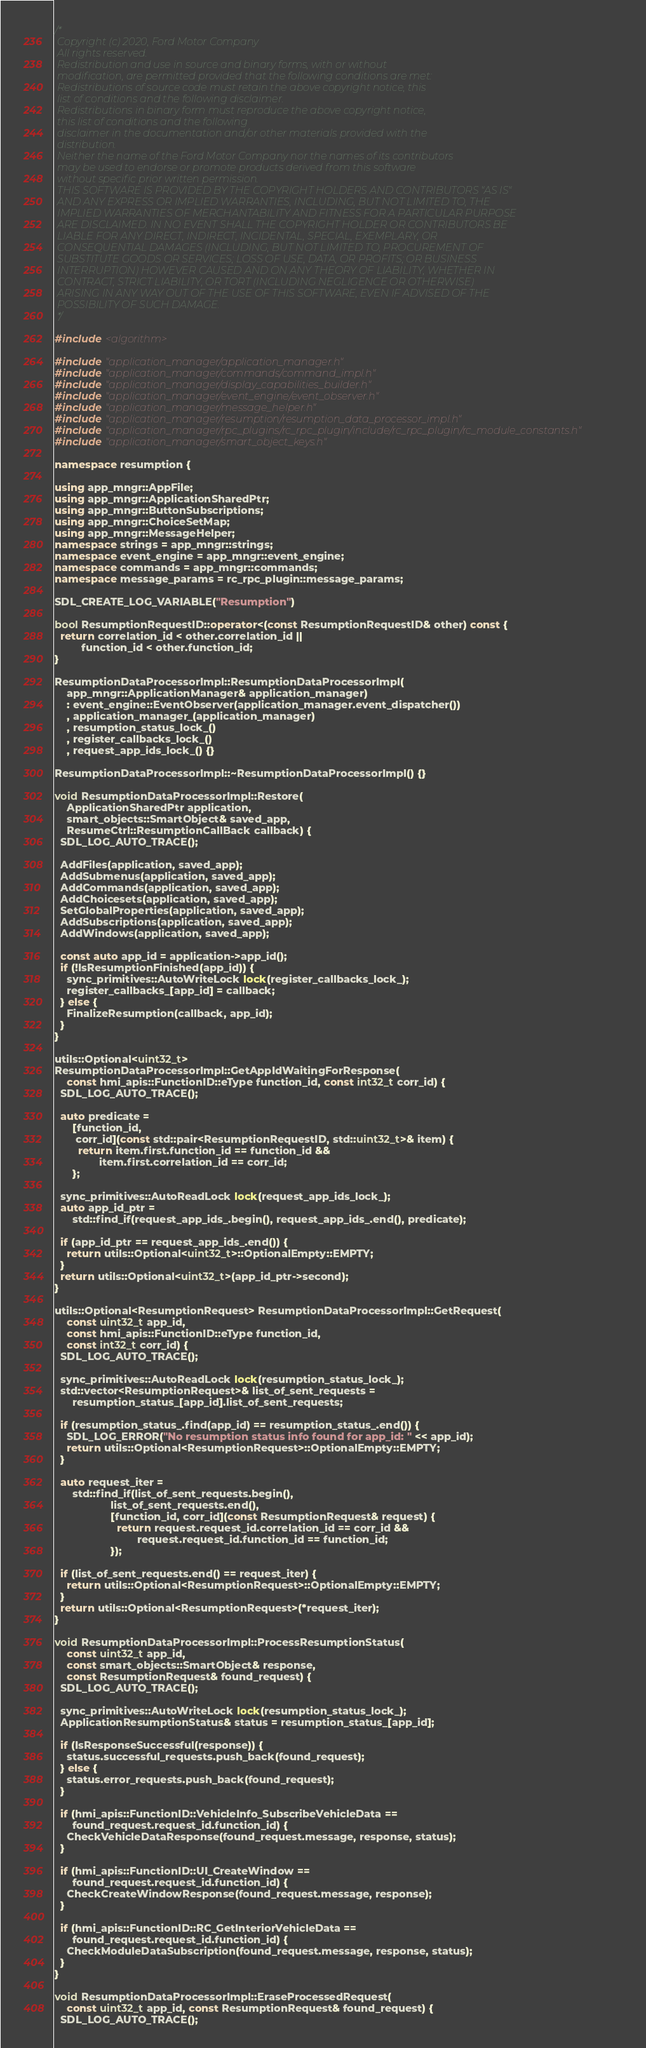<code> <loc_0><loc_0><loc_500><loc_500><_C++_>/*
 Copyright (c) 2020, Ford Motor Company
 All rights reserved.
 Redistribution and use in source and binary forms, with or without
 modification, are permitted provided that the following conditions are met:
 Redistributions of source code must retain the above copyright notice, this
 list of conditions and the following disclaimer.
 Redistributions in binary form must reproduce the above copyright notice,
 this list of conditions and the following
 disclaimer in the documentation and/or other materials provided with the
 distribution.
 Neither the name of the Ford Motor Company nor the names of its contributors
 may be used to endorse or promote products derived from this software
 without specific prior written permission.
 THIS SOFTWARE IS PROVIDED BY THE COPYRIGHT HOLDERS AND CONTRIBUTORS "AS IS"
 AND ANY EXPRESS OR IMPLIED WARRANTIES, INCLUDING, BUT NOT LIMITED TO, THE
 IMPLIED WARRANTIES OF MERCHANTABILITY AND FITNESS FOR A PARTICULAR PURPOSE
 ARE DISCLAIMED. IN NO EVENT SHALL THE COPYRIGHT HOLDER OR CONTRIBUTORS BE
 LIABLE FOR ANY DIRECT, INDIRECT, INCIDENTAL, SPECIAL, EXEMPLARY, OR
 CONSEQUENTIAL DAMAGES (INCLUDING, BUT NOT LIMITED TO, PROCUREMENT OF
 SUBSTITUTE GOODS OR SERVICES; LOSS OF USE, DATA, OR PROFITS; OR BUSINESS
 INTERRUPTION) HOWEVER CAUSED AND ON ANY THEORY OF LIABILITY, WHETHER IN
 CONTRACT, STRICT LIABILITY, OR TORT (INCLUDING NEGLIGENCE OR OTHERWISE)
 ARISING IN ANY WAY OUT OF THE USE OF THIS SOFTWARE, EVEN IF ADVISED OF THE
 POSSIBILITY OF SUCH DAMAGE.
 */

#include <algorithm>

#include "application_manager/application_manager.h"
#include "application_manager/commands/command_impl.h"
#include "application_manager/display_capabilities_builder.h"
#include "application_manager/event_engine/event_observer.h"
#include "application_manager/message_helper.h"
#include "application_manager/resumption/resumption_data_processor_impl.h"
#include "application_manager/rpc_plugins/rc_rpc_plugin/include/rc_rpc_plugin/rc_module_constants.h"
#include "application_manager/smart_object_keys.h"

namespace resumption {

using app_mngr::AppFile;
using app_mngr::ApplicationSharedPtr;
using app_mngr::ButtonSubscriptions;
using app_mngr::ChoiceSetMap;
using app_mngr::MessageHelper;
namespace strings = app_mngr::strings;
namespace event_engine = app_mngr::event_engine;
namespace commands = app_mngr::commands;
namespace message_params = rc_rpc_plugin::message_params;

SDL_CREATE_LOG_VARIABLE("Resumption")

bool ResumptionRequestID::operator<(const ResumptionRequestID& other) const {
  return correlation_id < other.correlation_id ||
         function_id < other.function_id;
}

ResumptionDataProcessorImpl::ResumptionDataProcessorImpl(
    app_mngr::ApplicationManager& application_manager)
    : event_engine::EventObserver(application_manager.event_dispatcher())
    , application_manager_(application_manager)
    , resumption_status_lock_()
    , register_callbacks_lock_()
    , request_app_ids_lock_() {}

ResumptionDataProcessorImpl::~ResumptionDataProcessorImpl() {}

void ResumptionDataProcessorImpl::Restore(
    ApplicationSharedPtr application,
    smart_objects::SmartObject& saved_app,
    ResumeCtrl::ResumptionCallBack callback) {
  SDL_LOG_AUTO_TRACE();

  AddFiles(application, saved_app);
  AddSubmenus(application, saved_app);
  AddCommands(application, saved_app);
  AddChoicesets(application, saved_app);
  SetGlobalProperties(application, saved_app);
  AddSubscriptions(application, saved_app);
  AddWindows(application, saved_app);

  const auto app_id = application->app_id();
  if (!IsResumptionFinished(app_id)) {
    sync_primitives::AutoWriteLock lock(register_callbacks_lock_);
    register_callbacks_[app_id] = callback;
  } else {
    FinalizeResumption(callback, app_id);
  }
}

utils::Optional<uint32_t>
ResumptionDataProcessorImpl::GetAppIdWaitingForResponse(
    const hmi_apis::FunctionID::eType function_id, const int32_t corr_id) {
  SDL_LOG_AUTO_TRACE();

  auto predicate =
      [function_id,
       corr_id](const std::pair<ResumptionRequestID, std::uint32_t>& item) {
        return item.first.function_id == function_id &&
               item.first.correlation_id == corr_id;
      };

  sync_primitives::AutoReadLock lock(request_app_ids_lock_);
  auto app_id_ptr =
      std::find_if(request_app_ids_.begin(), request_app_ids_.end(), predicate);

  if (app_id_ptr == request_app_ids_.end()) {
    return utils::Optional<uint32_t>::OptionalEmpty::EMPTY;
  }
  return utils::Optional<uint32_t>(app_id_ptr->second);
}

utils::Optional<ResumptionRequest> ResumptionDataProcessorImpl::GetRequest(
    const uint32_t app_id,
    const hmi_apis::FunctionID::eType function_id,
    const int32_t corr_id) {
  SDL_LOG_AUTO_TRACE();

  sync_primitives::AutoReadLock lock(resumption_status_lock_);
  std::vector<ResumptionRequest>& list_of_sent_requests =
      resumption_status_[app_id].list_of_sent_requests;

  if (resumption_status_.find(app_id) == resumption_status_.end()) {
    SDL_LOG_ERROR("No resumption status info found for app_id: " << app_id);
    return utils::Optional<ResumptionRequest>::OptionalEmpty::EMPTY;
  }

  auto request_iter =
      std::find_if(list_of_sent_requests.begin(),
                   list_of_sent_requests.end(),
                   [function_id, corr_id](const ResumptionRequest& request) {
                     return request.request_id.correlation_id == corr_id &&
                            request.request_id.function_id == function_id;
                   });

  if (list_of_sent_requests.end() == request_iter) {
    return utils::Optional<ResumptionRequest>::OptionalEmpty::EMPTY;
  }
  return utils::Optional<ResumptionRequest>(*request_iter);
}

void ResumptionDataProcessorImpl::ProcessResumptionStatus(
    const uint32_t app_id,
    const smart_objects::SmartObject& response,
    const ResumptionRequest& found_request) {
  SDL_LOG_AUTO_TRACE();

  sync_primitives::AutoWriteLock lock(resumption_status_lock_);
  ApplicationResumptionStatus& status = resumption_status_[app_id];

  if (IsResponseSuccessful(response)) {
    status.successful_requests.push_back(found_request);
  } else {
    status.error_requests.push_back(found_request);
  }

  if (hmi_apis::FunctionID::VehicleInfo_SubscribeVehicleData ==
      found_request.request_id.function_id) {
    CheckVehicleDataResponse(found_request.message, response, status);
  }

  if (hmi_apis::FunctionID::UI_CreateWindow ==
      found_request.request_id.function_id) {
    CheckCreateWindowResponse(found_request.message, response);
  }

  if (hmi_apis::FunctionID::RC_GetInteriorVehicleData ==
      found_request.request_id.function_id) {
    CheckModuleDataSubscription(found_request.message, response, status);
  }
}

void ResumptionDataProcessorImpl::EraseProcessedRequest(
    const uint32_t app_id, const ResumptionRequest& found_request) {
  SDL_LOG_AUTO_TRACE();
</code> 